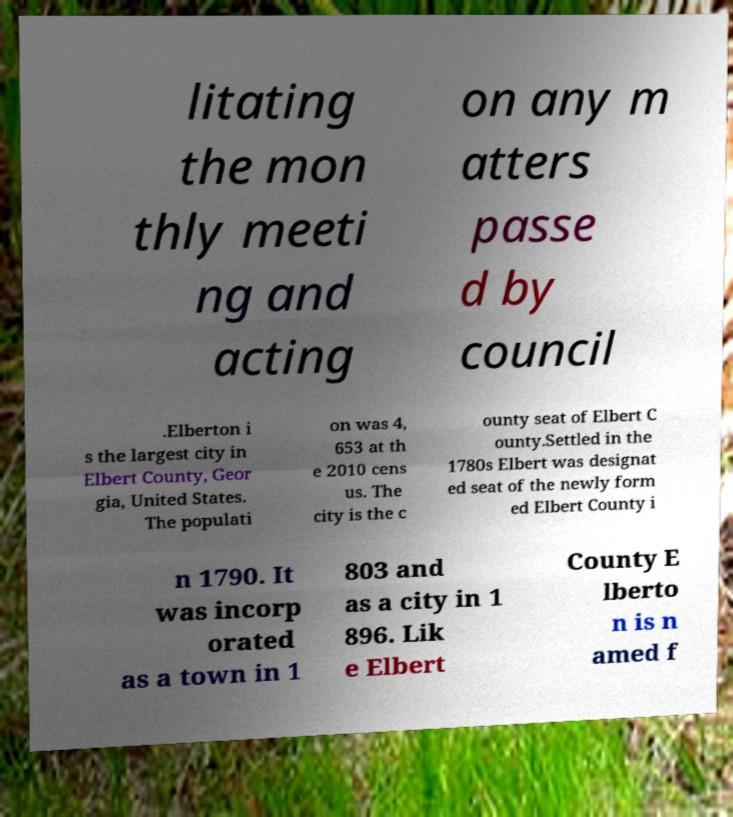Can you accurately transcribe the text from the provided image for me? litating the mon thly meeti ng and acting on any m atters passe d by council .Elberton i s the largest city in Elbert County, Geor gia, United States. The populati on was 4, 653 at th e 2010 cens us. The city is the c ounty seat of Elbert C ounty.Settled in the 1780s Elbert was designat ed seat of the newly form ed Elbert County i n 1790. It was incorp orated as a town in 1 803 and as a city in 1 896. Lik e Elbert County E lberto n is n amed f 